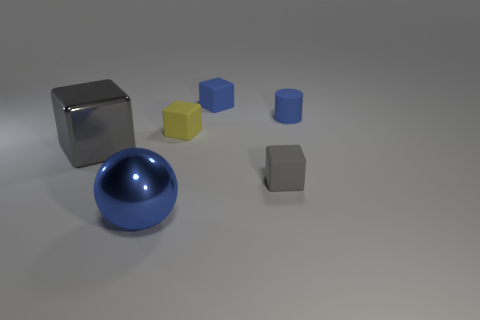Subtract all yellow blocks. How many blocks are left? 3 Subtract all tiny gray cubes. How many cubes are left? 3 Subtract all cyan blocks. Subtract all blue cylinders. How many blocks are left? 4 Add 1 big green metal blocks. How many objects exist? 7 Subtract all cubes. How many objects are left? 2 Add 5 small yellow blocks. How many small yellow blocks are left? 6 Add 2 gray matte objects. How many gray matte objects exist? 3 Subtract 0 cyan spheres. How many objects are left? 6 Subtract all tiny blue objects. Subtract all yellow matte blocks. How many objects are left? 3 